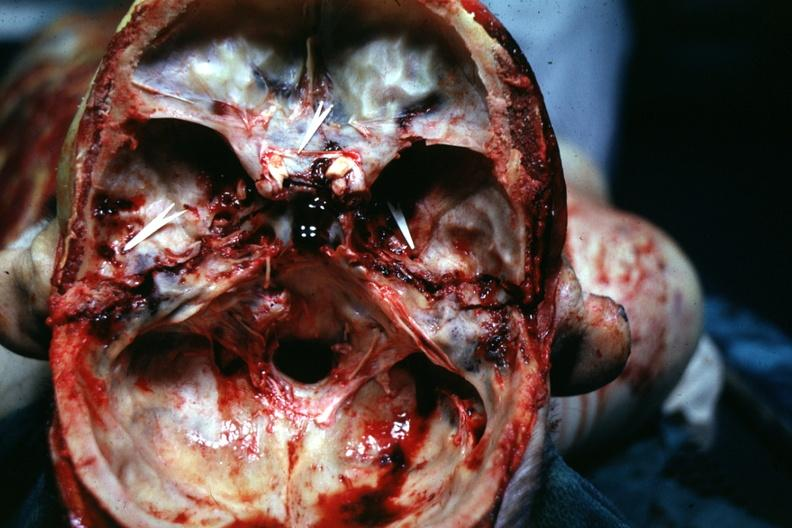s beckwith-wiedemann syndrome present?
Answer the question using a single word or phrase. No 